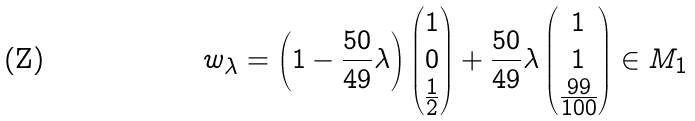Convert formula to latex. <formula><loc_0><loc_0><loc_500><loc_500>w _ { \lambda } = \left ( 1 - \frac { 5 0 } { 4 9 } \lambda \right ) \begin{pmatrix} 1 \\ 0 \\ \frac { 1 } { 2 } \end{pmatrix} + \frac { 5 0 } { 4 9 } \lambda \begin{pmatrix} 1 \\ 1 \\ \frac { 9 9 } { 1 0 0 } \end{pmatrix} \in M _ { 1 }</formula> 